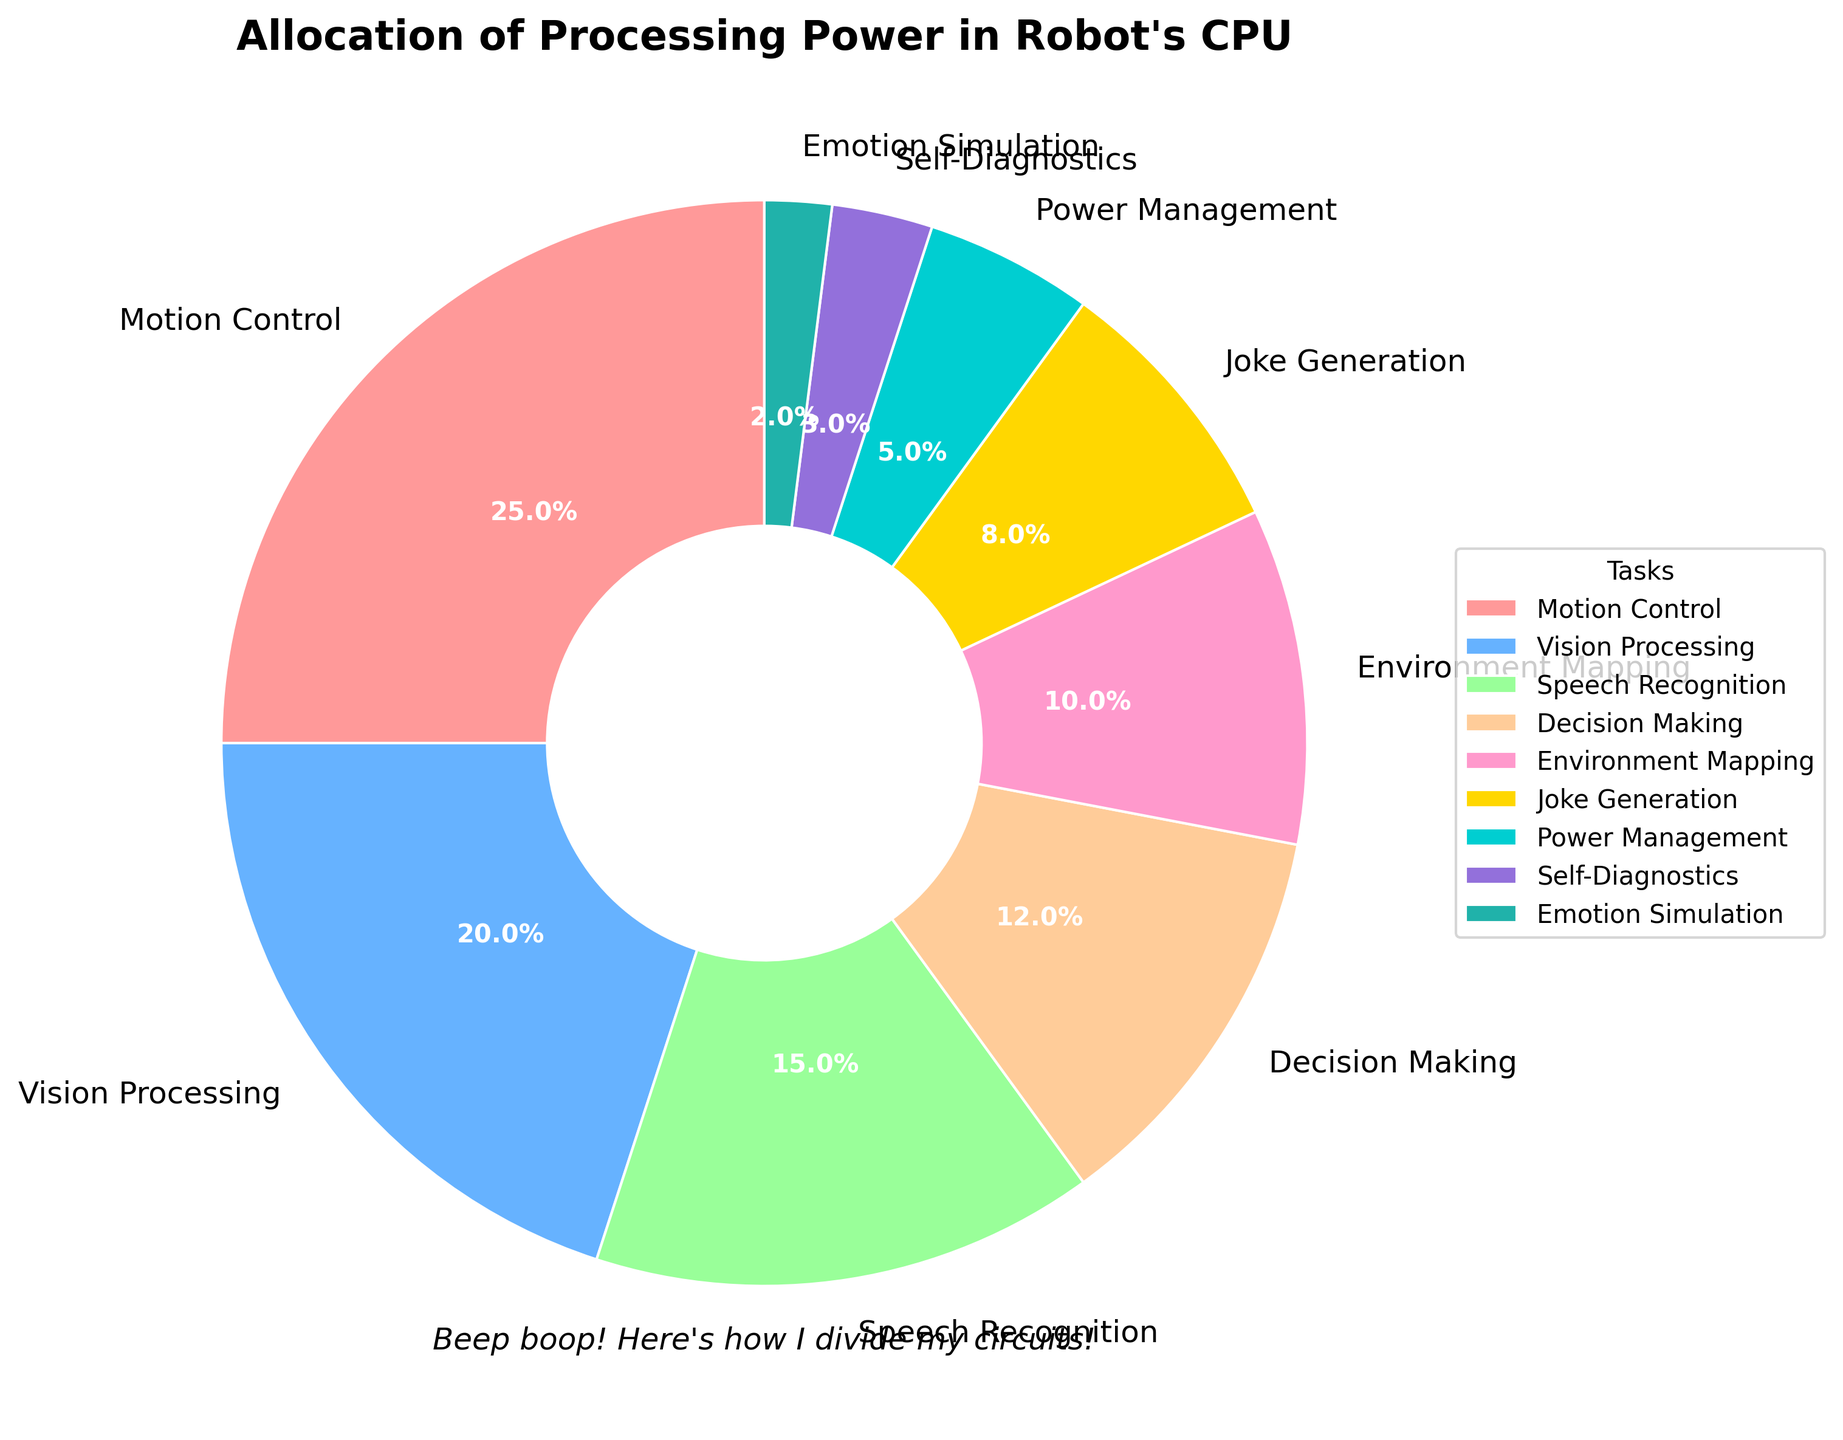What task uses the most CPU power? Motion Control uses the most CPU power. This can be seen by examining the pie chart slice with the largest percentage, which is 25% allocated to Motion Control.
Answer: Motion Control What is the combined CPU power used by Vision Processing and Speech Recognition? To find the combined CPU power, sum the percentages for Vision Processing (20%) and Speech Recognition (15%). 20% + 15% = 35%.
Answer: 35% Which tasks use less CPU power than Power Management? Power Management uses 5% of the CPU power. Tasks that use less are: Self-Diagnostics (3%) and Emotion Simulation (2%).
Answer: Self-Diagnostics, Emotion Simulation What is the difference in CPU power allocation between Decision Making and Environment Mapping? Decision Making uses 12% and Environment Mapping uses 10%. The difference is 12% - 10% = 2%.
Answer: 2% What task has the smallest allocation of CPU power? The smallest slice in the pie chart represents Emotion Simulation with a 2% allocation.
Answer: Emotion Simulation Is the CPU power allocation for Joke Generation more than or less than Power Management? Joke Generation uses 8% of the CPU power, while Power Management uses 5%. Since 8% is more than 5%, Joke Generation uses more CPU power than Power Management.
Answer: More How much more CPU power does Motion Control use compared to Speech Recognition? Motion Control uses 25% and Speech Recognition uses 15%. The difference is 25% - 15% = 10%.
Answer: 10% What is the combined percentage allocation for all tasks except for the one with the highest allocation? The tasks except Motion Control sum up to 75%. Calculated as 100% (total) - 25% (Motion Control) = 75%.
Answer: 75% What's the percentage difference between the highest and the lowest CPU power allocations? The highest allocation is Motion Control at 25%, and the lowest is Emotion Simulation at 2%. The difference is 25% - 2% = 23%.
Answer: 23% Which tasks together constitute exactly 50% of the CPU power allocation? Combining Vision Processing (20%), Speech Recognition (15%), and Environment Mapping (10%) equals 45%. Additionally, Joke Generation at 8% would exceed 50%. Adding Decision Making (12%) to Vision Processing and Speech Recognition results in 47%, which is still under 50%. There is no exact combination that sums to 50%.
Answer: None 